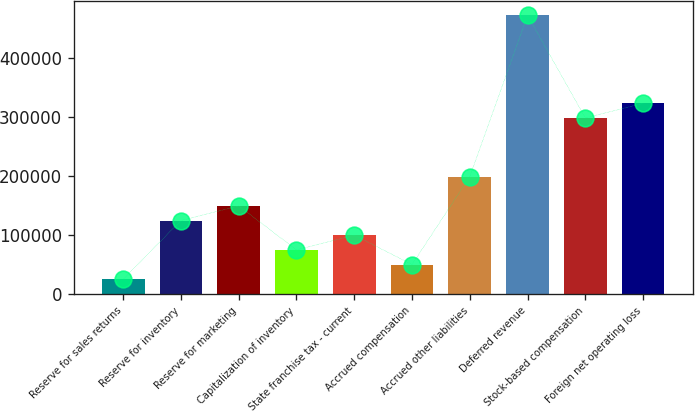Convert chart to OTSL. <chart><loc_0><loc_0><loc_500><loc_500><bar_chart><fcel>Reserve for sales returns<fcel>Reserve for inventory<fcel>Reserve for marketing<fcel>Capitalization of inventory<fcel>State franchise tax - current<fcel>Accrued compensation<fcel>Accrued other liabilities<fcel>Deferred revenue<fcel>Stock-based compensation<fcel>Foreign net operating loss<nl><fcel>24969.9<fcel>124454<fcel>149324<fcel>74711.7<fcel>99582.6<fcel>49840.8<fcel>199066<fcel>472646<fcel>298550<fcel>323421<nl></chart> 